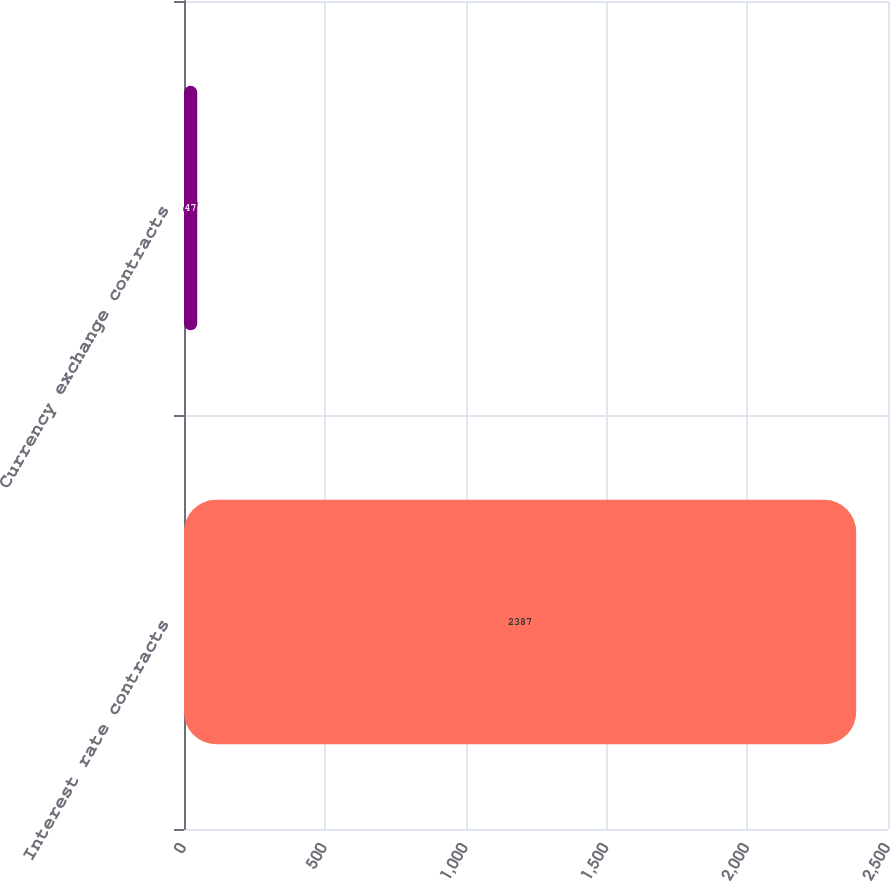<chart> <loc_0><loc_0><loc_500><loc_500><bar_chart><fcel>Interest rate contracts<fcel>Currency exchange contracts<nl><fcel>2387<fcel>47<nl></chart> 